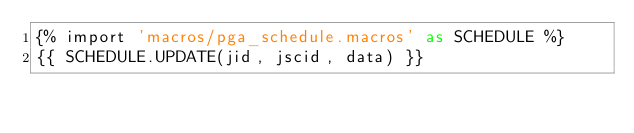Convert code to text. <code><loc_0><loc_0><loc_500><loc_500><_SQL_>{% import 'macros/pga_schedule.macros' as SCHEDULE %}
{{ SCHEDULE.UPDATE(jid, jscid, data) }}
</code> 